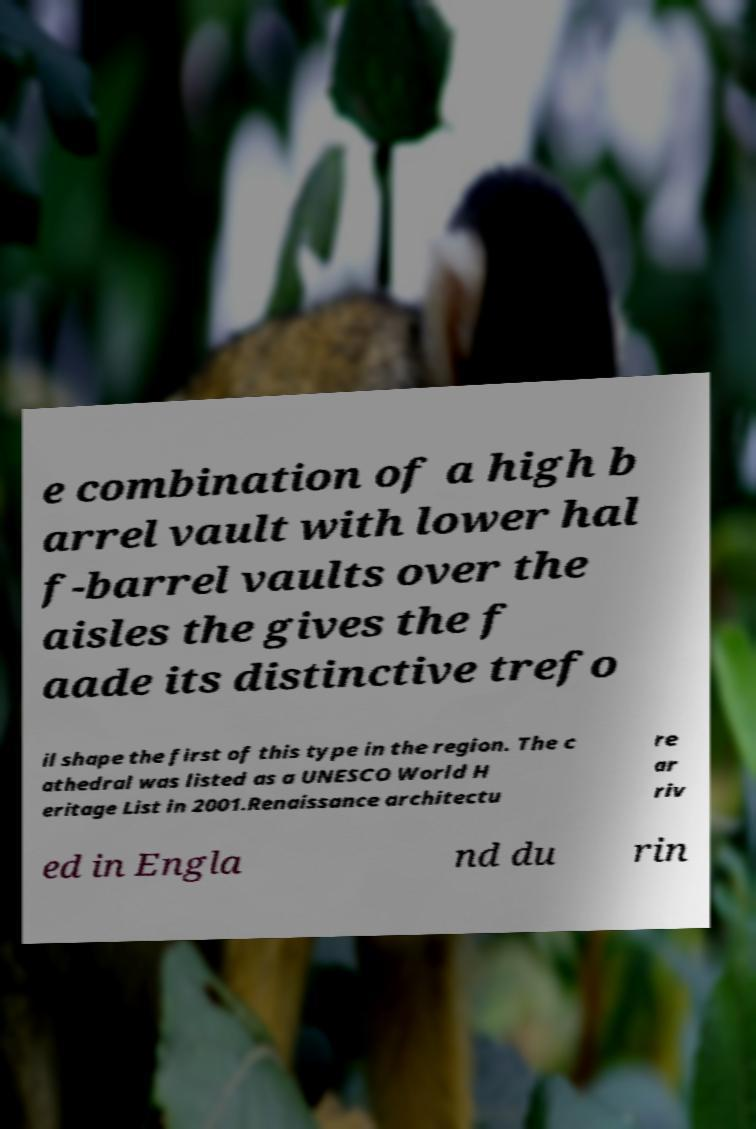There's text embedded in this image that I need extracted. Can you transcribe it verbatim? e combination of a high b arrel vault with lower hal f-barrel vaults over the aisles the gives the f aade its distinctive trefo il shape the first of this type in the region. The c athedral was listed as a UNESCO World H eritage List in 2001.Renaissance architectu re ar riv ed in Engla nd du rin 